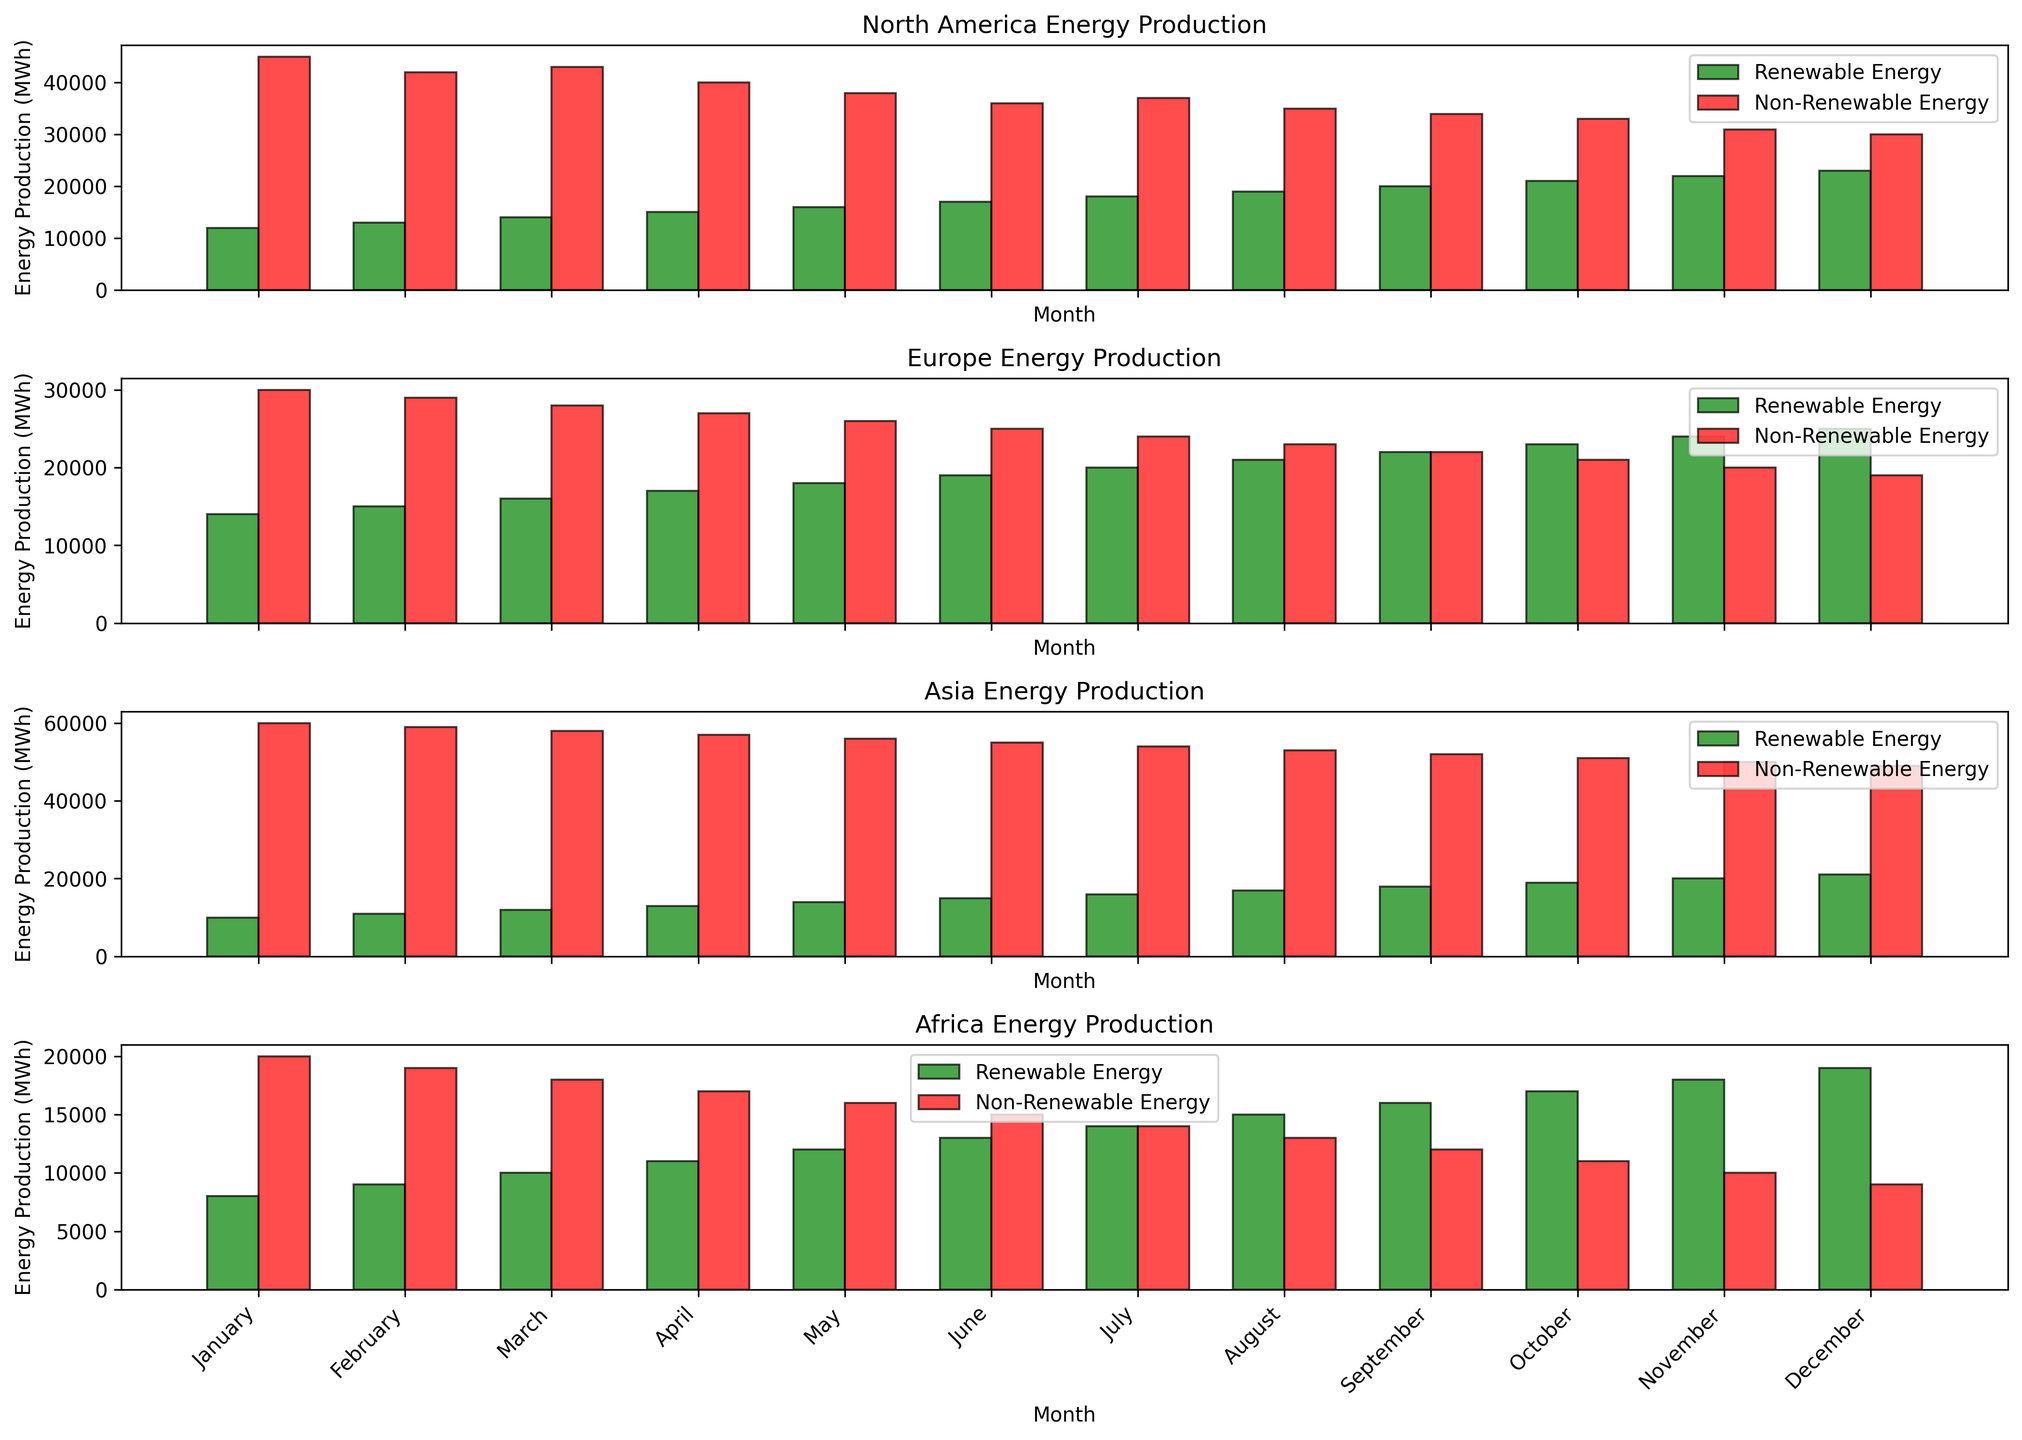What's the difference in renewable energy production between January and December in North America? To find the difference, identify the renewable energy production values for January and December in North America (12000 MWh and 23000 MWh, respectively) and subtract the January value from the December value: 23000 - 12000.
Answer: 11000 MWh Which region has the highest renewable energy production in July? Check the renewable energy production values for July in all regions and compare them: North America (18000 MWh), Europe (20000 MWh), Asia (16000 MWh), and Africa (14000 MWh). The highest value is 20000 MWh in Europe.
Answer: Europe Which months in Asia have higher non-renewable energy production than renewable energy production? Compare the renewable and non-renewable energy production values for each month in Asia. For all months, non-renewable energy production exceeds renewable energy production. So, every month qualifies.
Answer: January to December What is the total energy production (renewable + non-renewable) in Europe for June? Add the renewable and non-renewable energy production values for June in Europe: 19000 MWh (renewable) + 25000 MWh (non-renewable).
Answer: 44000 MWh In which month does Africa achieve equal levels of renewable and non-renewable energy production? Look for the month where renewable and non-renewable energy production values are the same in Africa. In July, both are 14000 MWh.
Answer: July What is the average non-renewable energy production in North America across the year? Sum all the non-renewable energy production values for North America from January to December, then divide by the number of months (12): (45000 + 42000 + 43000 + 40000 + 38000 + 36000 + 37000 + 35000 + 34000 + 33000 + 31000 + 30000) / 12.
Answer: 37000 MWh How does the renewable energy production in December in Africa compare to the same month in North America? Compare the renewable energy production values for December in both regions: Africa (19000 MWh) and North America (23000 MWh). North America's production is higher.
Answer: North America's is higher What is the maximum renewable energy production value across all regions and months? Identify the highest renewable energy production value among all data points. The highest value is 25000 MWh in December in Europe.
Answer: 25000 MWh Which region shows a decreasing trend in non-renewable energy production throughout the year? Observe the non-renewable energy production values for each region month by month to identify any decreasing trends. Europe shows a consistent decrease each month.
Answer: Europe What's the ratio of renewable to non-renewable energy production in April for North America? Divide the renewable energy production by the non-renewable energy production for April in North America: 15000 MWh / 40000 MWh.
Answer: 0.375 